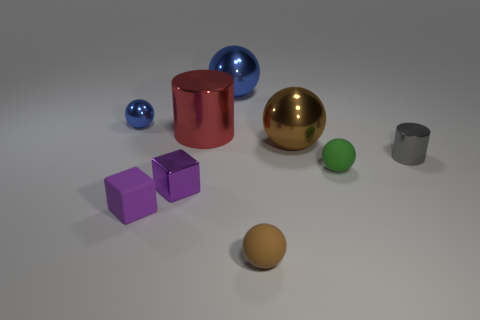Subtract 2 spheres. How many spheres are left? 3 Subtract all large brown metallic balls. How many balls are left? 4 Subtract all green spheres. How many spheres are left? 4 Subtract all purple balls. Subtract all blue blocks. How many balls are left? 5 Add 1 small green balls. How many objects exist? 10 Subtract all cubes. How many objects are left? 7 Subtract all metallic cylinders. Subtract all tiny blue metal things. How many objects are left? 6 Add 8 tiny metal blocks. How many tiny metal blocks are left? 9 Add 6 small cyan shiny cubes. How many small cyan shiny cubes exist? 6 Subtract 1 green spheres. How many objects are left? 8 